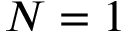Convert formula to latex. <formula><loc_0><loc_0><loc_500><loc_500>N = 1</formula> 